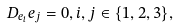<formula> <loc_0><loc_0><loc_500><loc_500>D _ { e _ { i } } e _ { j } = 0 , i , j \in \{ 1 , 2 , 3 \} ,</formula> 